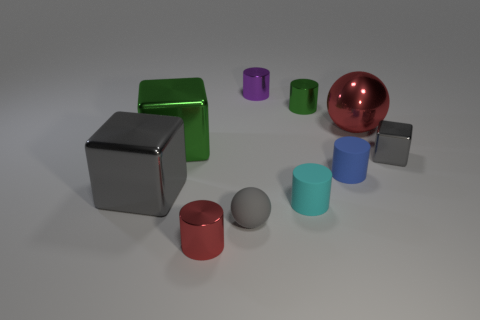Subtract all big gray blocks. How many blocks are left? 2 Subtract all gray blocks. How many were subtracted if there are1gray blocks left? 1 Subtract 2 cubes. How many cubes are left? 1 Subtract all blue blocks. Subtract all brown cylinders. How many blocks are left? 3 Subtract all gray cylinders. How many green blocks are left? 1 Subtract all purple metal objects. Subtract all small cyan matte objects. How many objects are left? 8 Add 4 small green cylinders. How many small green cylinders are left? 5 Add 3 small blue matte things. How many small blue matte things exist? 4 Subtract all green cylinders. How many cylinders are left? 4 Subtract 1 red cylinders. How many objects are left? 9 